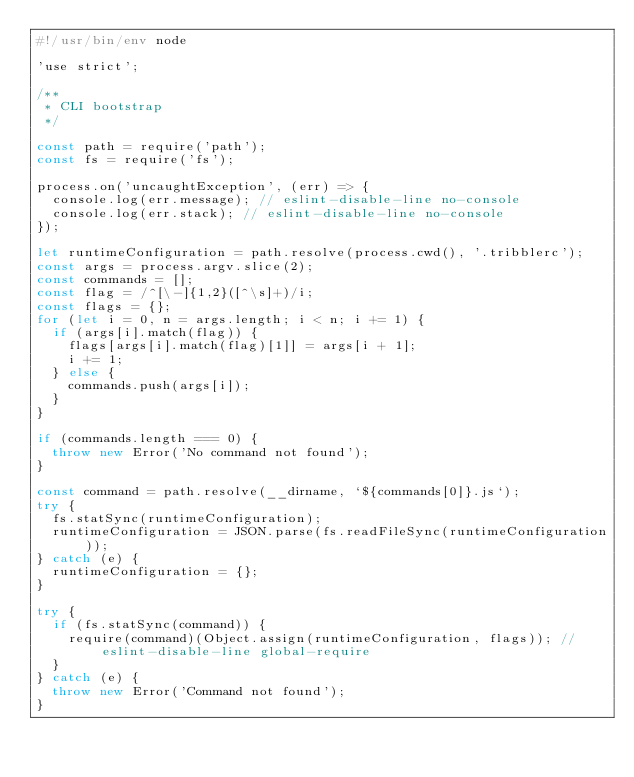<code> <loc_0><loc_0><loc_500><loc_500><_JavaScript_>#!/usr/bin/env node

'use strict';

/**
 * CLI bootstrap
 */

const path = require('path');
const fs = require('fs');

process.on('uncaughtException', (err) => {
	console.log(err.message); // eslint-disable-line no-console
	console.log(err.stack); // eslint-disable-line no-console
});

let runtimeConfiguration = path.resolve(process.cwd(), '.tribblerc');
const args = process.argv.slice(2);
const commands = [];
const flag = /^[\-]{1,2}([^\s]+)/i;
const flags = {};
for (let i = 0, n = args.length; i < n; i += 1) {
	if (args[i].match(flag)) {
		flags[args[i].match(flag)[1]] = args[i + 1];
		i += 1;
	} else {
		commands.push(args[i]);
	}
}

if (commands.length === 0) {
	throw new Error('No command not found');
}

const command = path.resolve(__dirname, `${commands[0]}.js`);
try {
	fs.statSync(runtimeConfiguration);
	runtimeConfiguration = JSON.parse(fs.readFileSync(runtimeConfiguration));
} catch (e) {
	runtimeConfiguration = {};
}

try {
	if (fs.statSync(command)) {
		require(command)(Object.assign(runtimeConfiguration, flags)); // eslint-disable-line global-require
	}
} catch (e) {
	throw new Error('Command not found');
}
</code> 